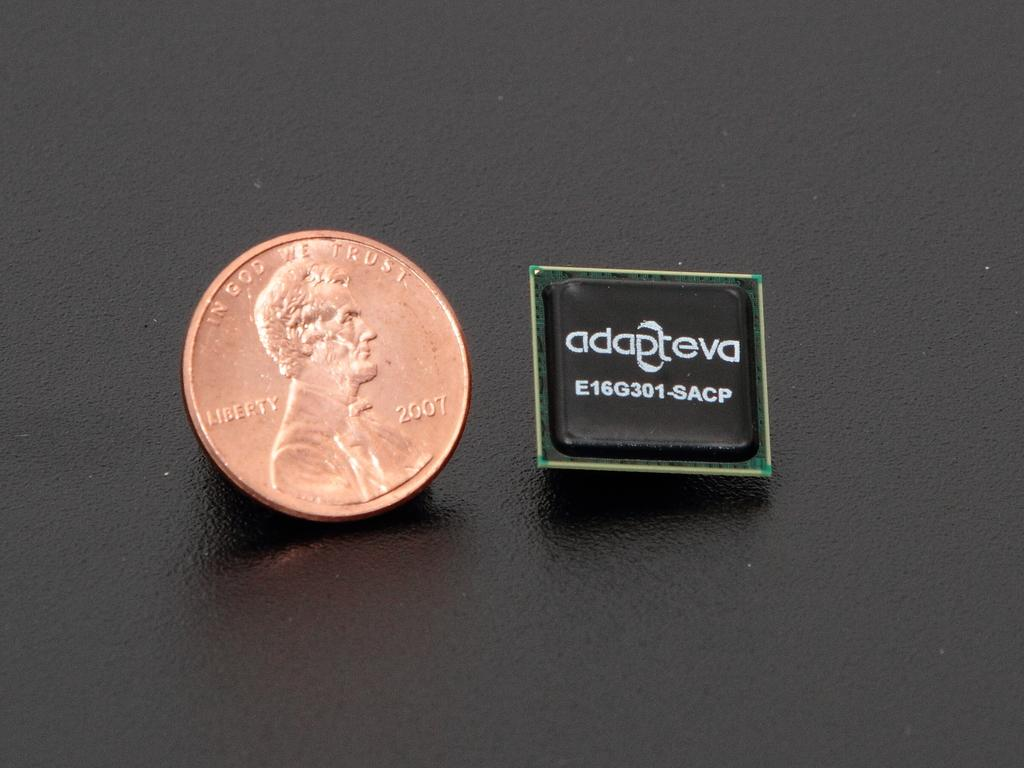<image>
Describe the image concisely. A penny is placed next to an adapteva chip. 